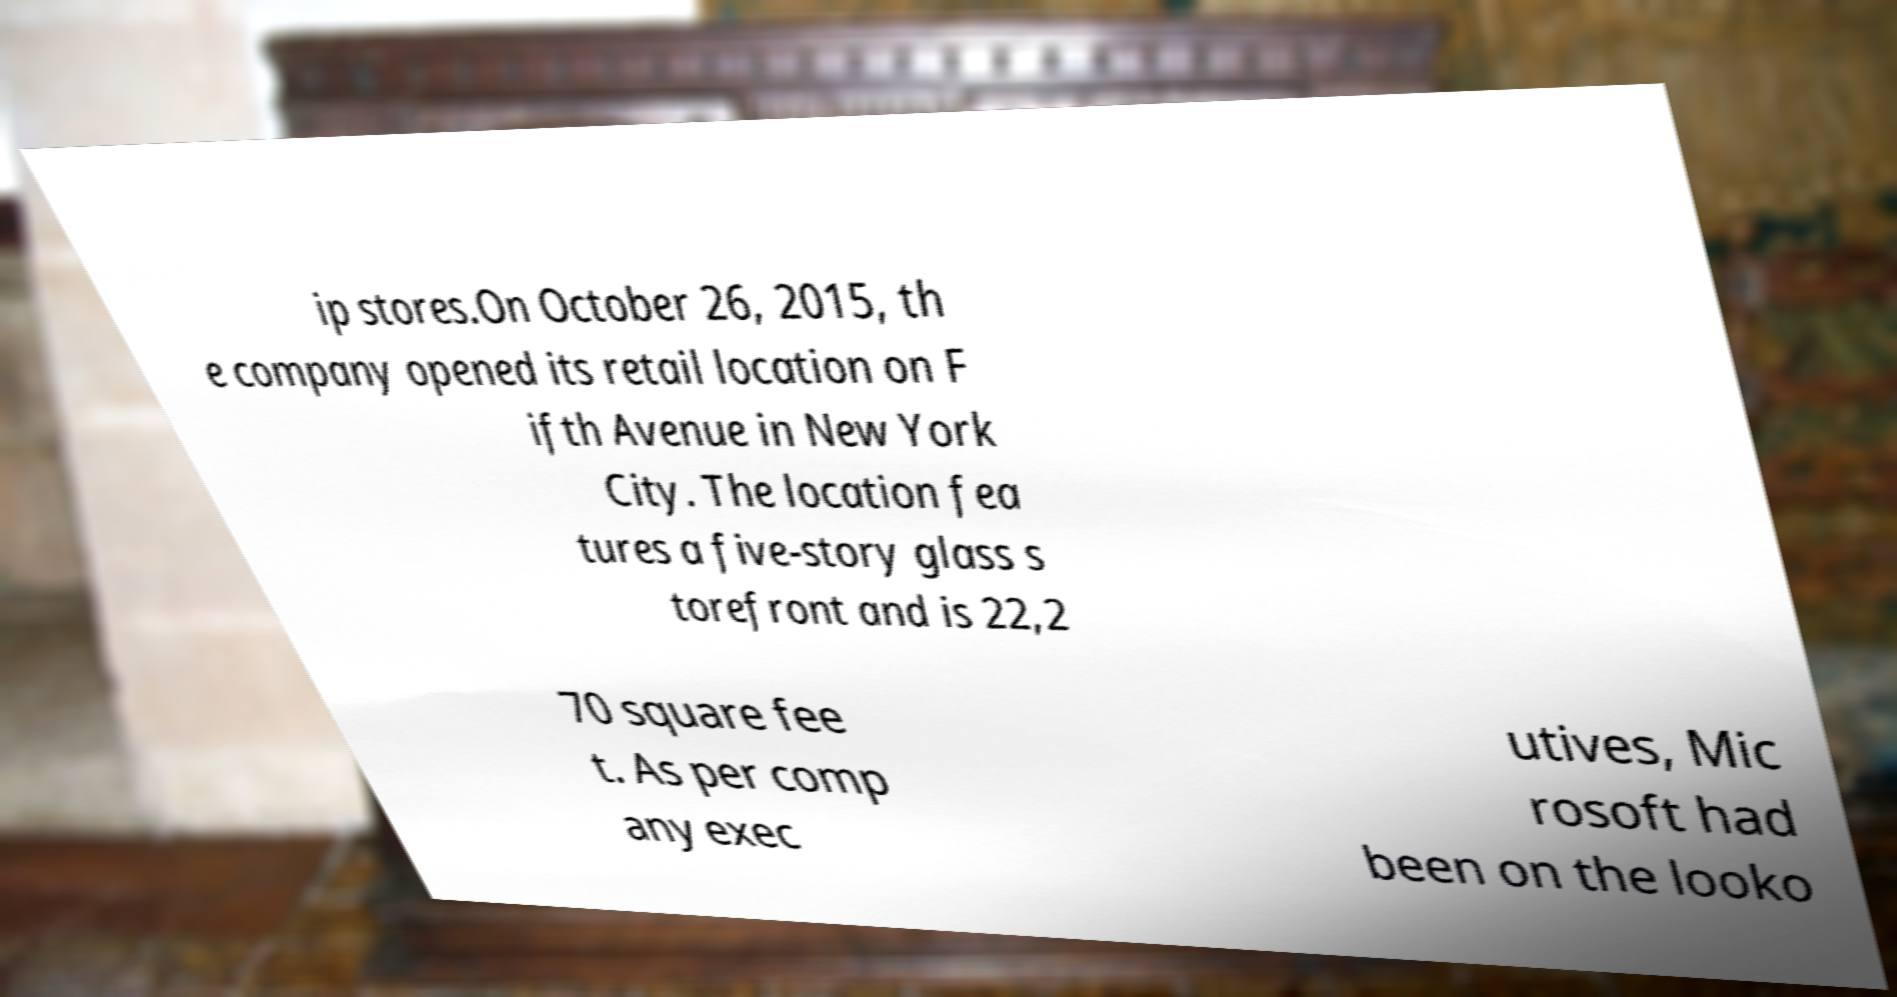Can you accurately transcribe the text from the provided image for me? ip stores.On October 26, 2015, th e company opened its retail location on F ifth Avenue in New York City. The location fea tures a five-story glass s torefront and is 22,2 70 square fee t. As per comp any exec utives, Mic rosoft had been on the looko 